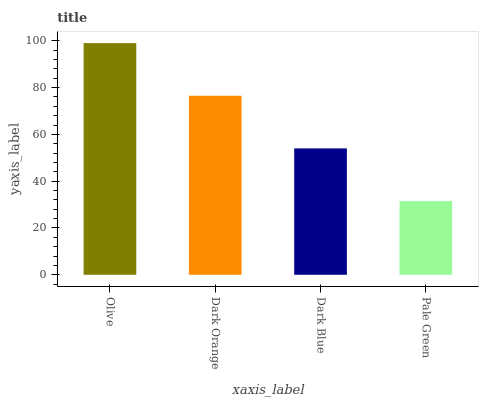Is Pale Green the minimum?
Answer yes or no. Yes. Is Olive the maximum?
Answer yes or no. Yes. Is Dark Orange the minimum?
Answer yes or no. No. Is Dark Orange the maximum?
Answer yes or no. No. Is Olive greater than Dark Orange?
Answer yes or no. Yes. Is Dark Orange less than Olive?
Answer yes or no. Yes. Is Dark Orange greater than Olive?
Answer yes or no. No. Is Olive less than Dark Orange?
Answer yes or no. No. Is Dark Orange the high median?
Answer yes or no. Yes. Is Dark Blue the low median?
Answer yes or no. Yes. Is Dark Blue the high median?
Answer yes or no. No. Is Olive the low median?
Answer yes or no. No. 